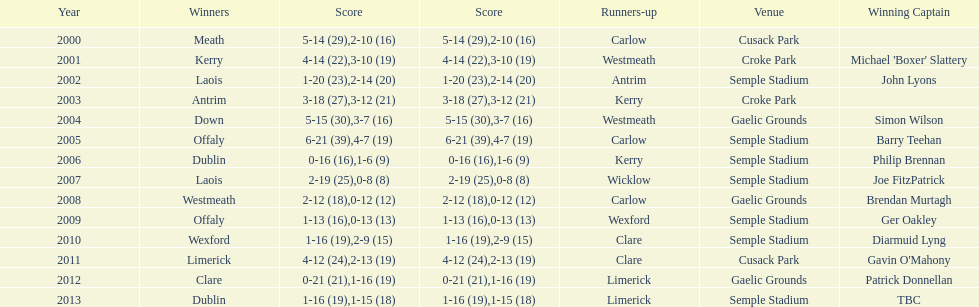What is the difference in the scores in 2000? 13. 